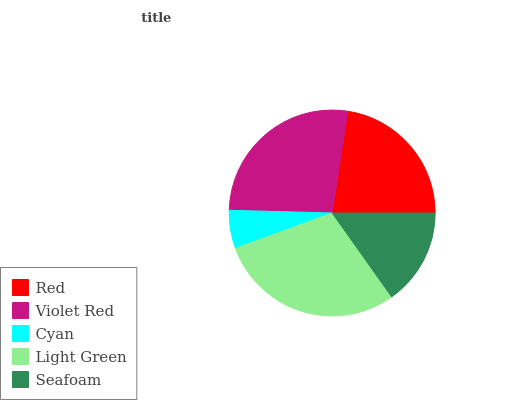Is Cyan the minimum?
Answer yes or no. Yes. Is Light Green the maximum?
Answer yes or no. Yes. Is Violet Red the minimum?
Answer yes or no. No. Is Violet Red the maximum?
Answer yes or no. No. Is Violet Red greater than Red?
Answer yes or no. Yes. Is Red less than Violet Red?
Answer yes or no. Yes. Is Red greater than Violet Red?
Answer yes or no. No. Is Violet Red less than Red?
Answer yes or no. No. Is Red the high median?
Answer yes or no. Yes. Is Red the low median?
Answer yes or no. Yes. Is Seafoam the high median?
Answer yes or no. No. Is Cyan the low median?
Answer yes or no. No. 